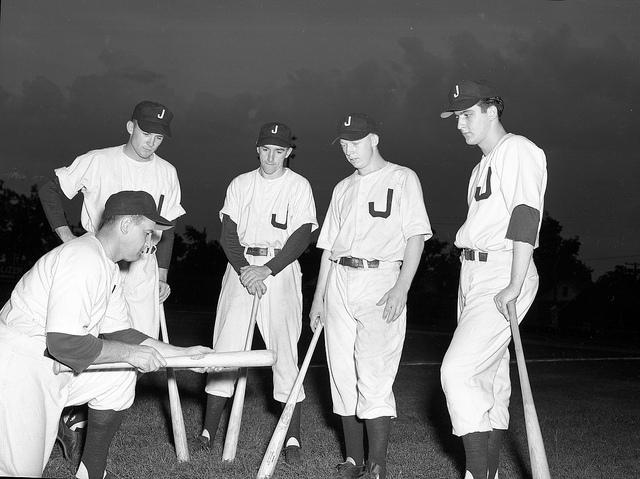What is on the men's heads?
Give a very brief answer. Hats. What letter is on the men's jerseys?
Write a very short answer. J. How many people are in the picture?
Answer briefly. 5. What are the men learning?
Answer briefly. Baseball. 